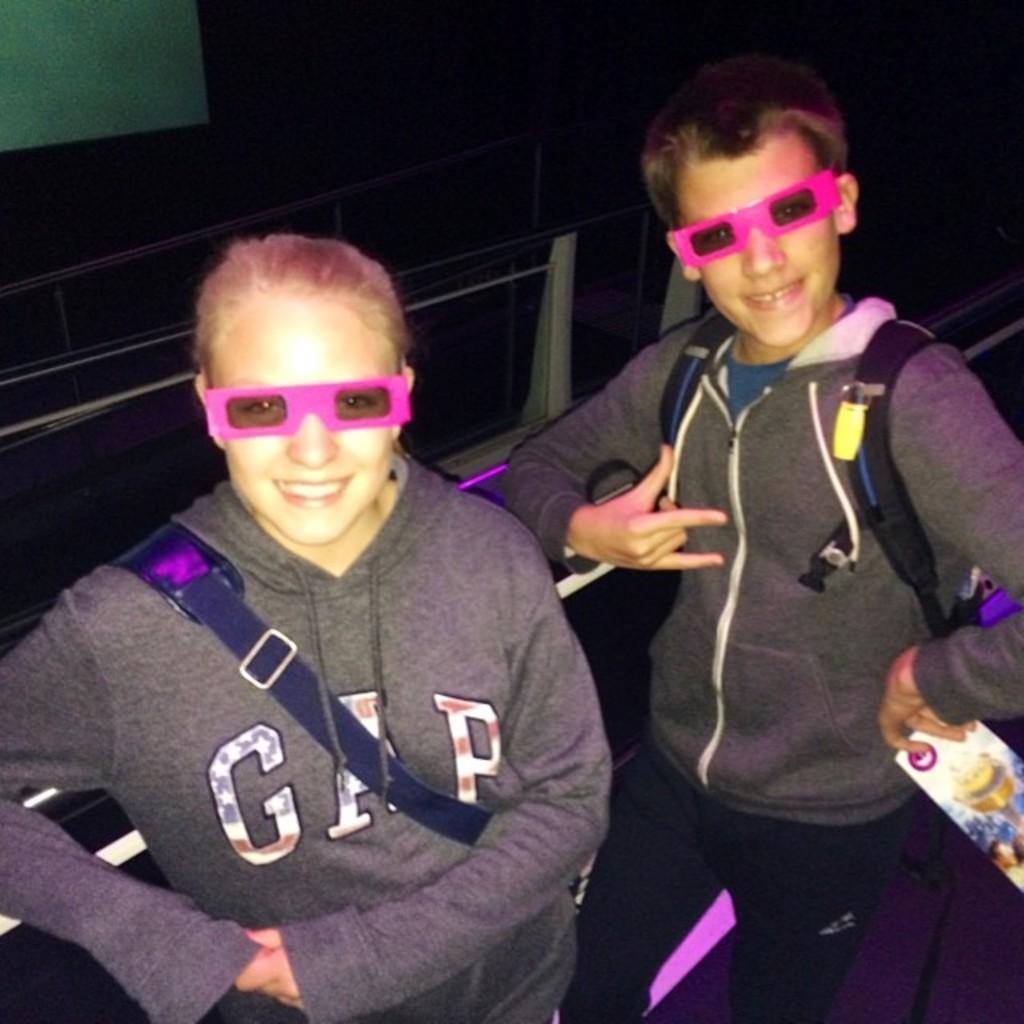In one or two sentences, can you explain what this image depicts? In this image there are two persons standing with a smile on their face, one of them is holding an object in his hand. The background is dark and there are few objects which is not clear. 